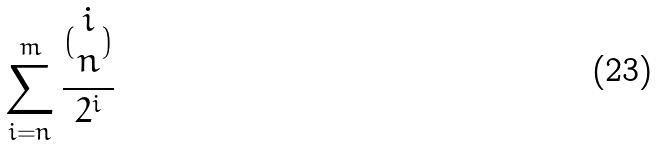Convert formula to latex. <formula><loc_0><loc_0><loc_500><loc_500>\sum _ { i = n } ^ { m } \frac { ( \begin{matrix} i \\ n \end{matrix} ) } { 2 ^ { i } }</formula> 